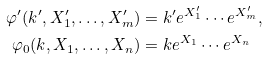<formula> <loc_0><loc_0><loc_500><loc_500>\varphi ^ { \prime } ( k ^ { \prime } , X ^ { \prime } _ { 1 } , \dots , X ^ { \prime } _ { m } ) & = k ^ { \prime } e ^ { X ^ { \prime } _ { 1 } } \cdots e ^ { X ^ { \prime } _ { m } } , \\ \varphi _ { 0 } ( k , X _ { 1 } , \dots , X _ { n } ) & = k e ^ { X _ { 1 } } \cdots e ^ { X _ { n } }</formula> 